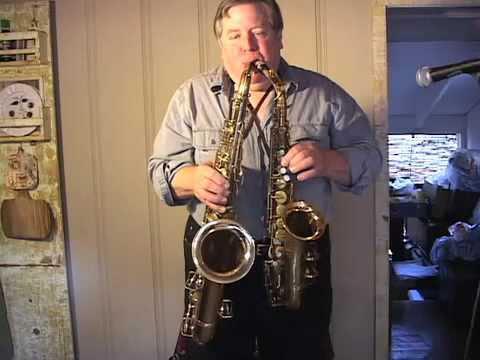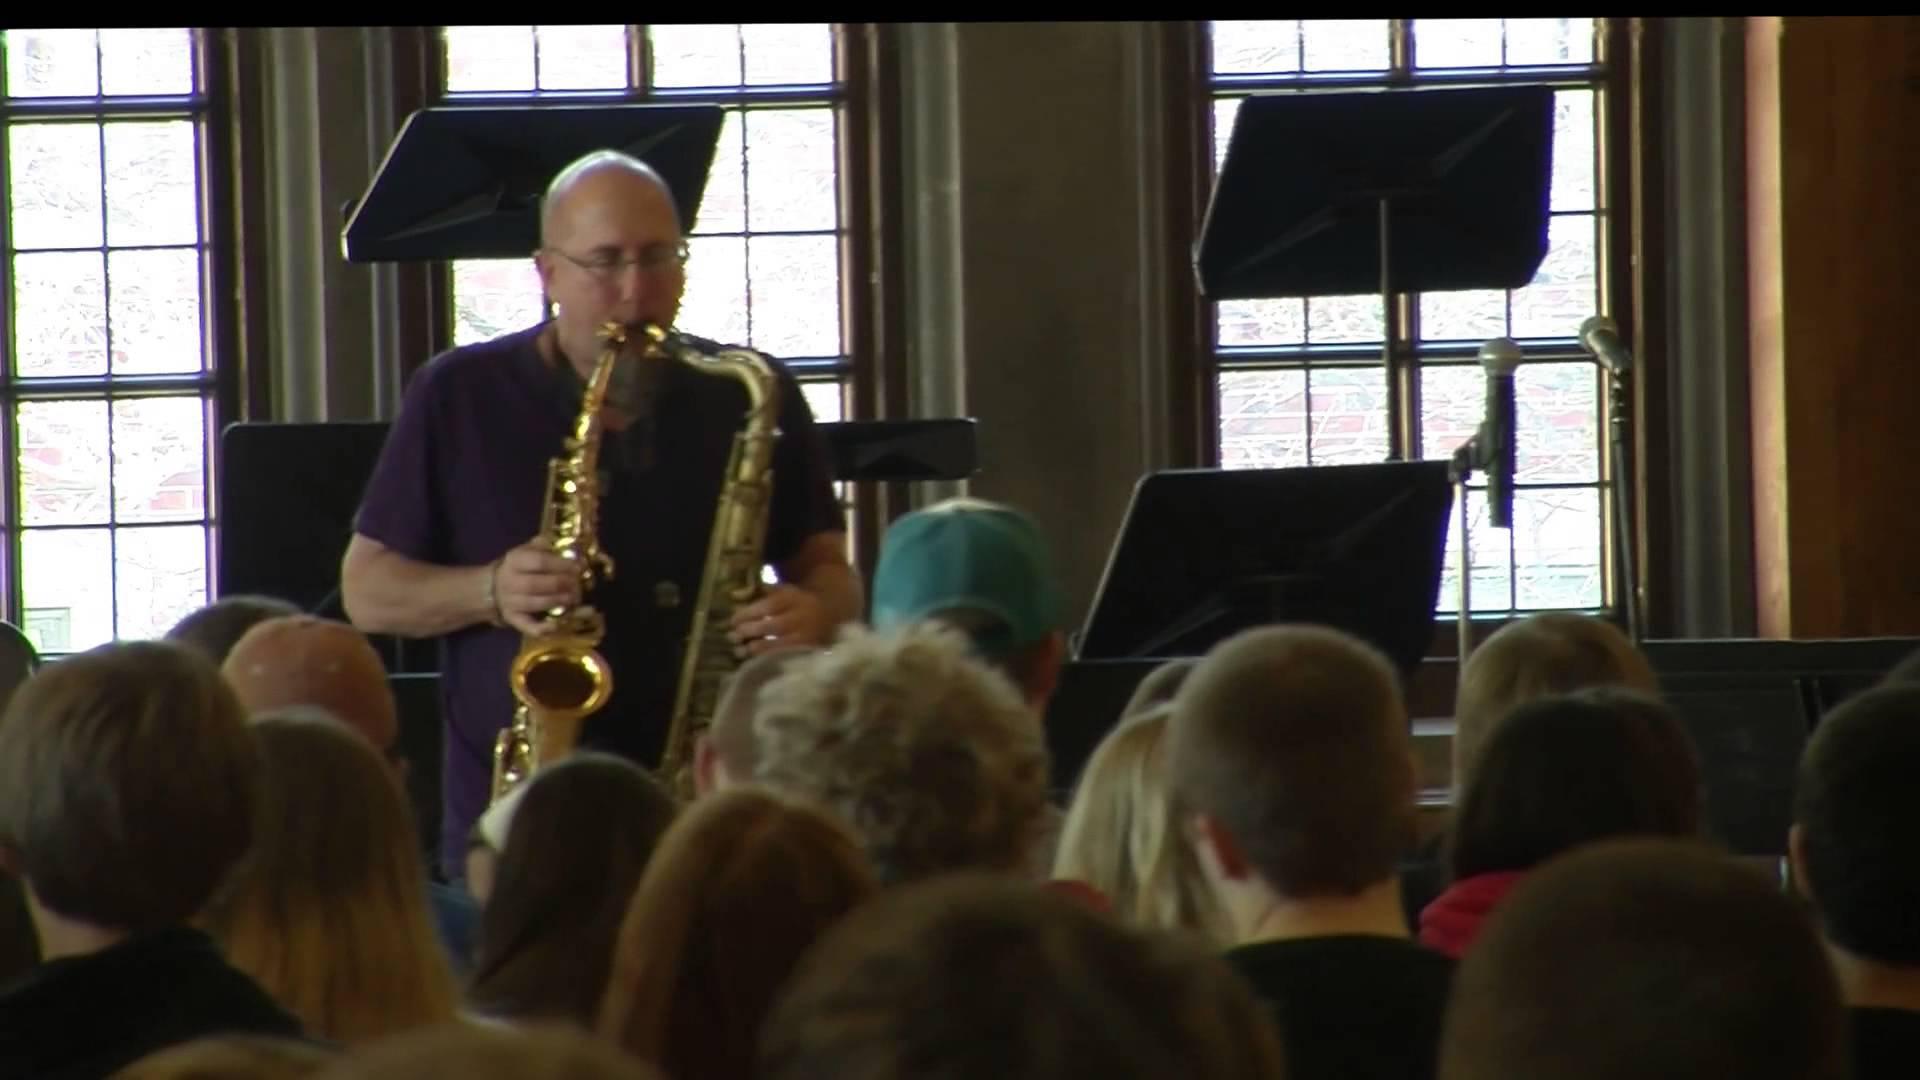The first image is the image on the left, the second image is the image on the right. Examine the images to the left and right. Is the description "A musician is holding a guitar in the right image." accurate? Answer yes or no. No. The first image is the image on the left, the second image is the image on the right. Assess this claim about the two images: "In one of the image there is a man playing a guitar in his lap.". Correct or not? Answer yes or no. No. 